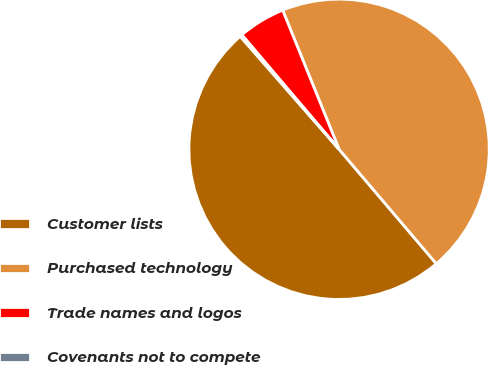Convert chart to OTSL. <chart><loc_0><loc_0><loc_500><loc_500><pie_chart><fcel>Customer lists<fcel>Purchased technology<fcel>Trade names and logos<fcel>Covenants not to compete<nl><fcel>49.77%<fcel>44.92%<fcel>5.08%<fcel>0.23%<nl></chart> 